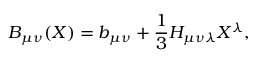Convert formula to latex. <formula><loc_0><loc_0><loc_500><loc_500>B _ { \mu \nu } ( X ) = b _ { \mu \nu } + \frac { 1 } { 3 } H _ { \mu \nu \lambda } X ^ { \lambda } ,</formula> 